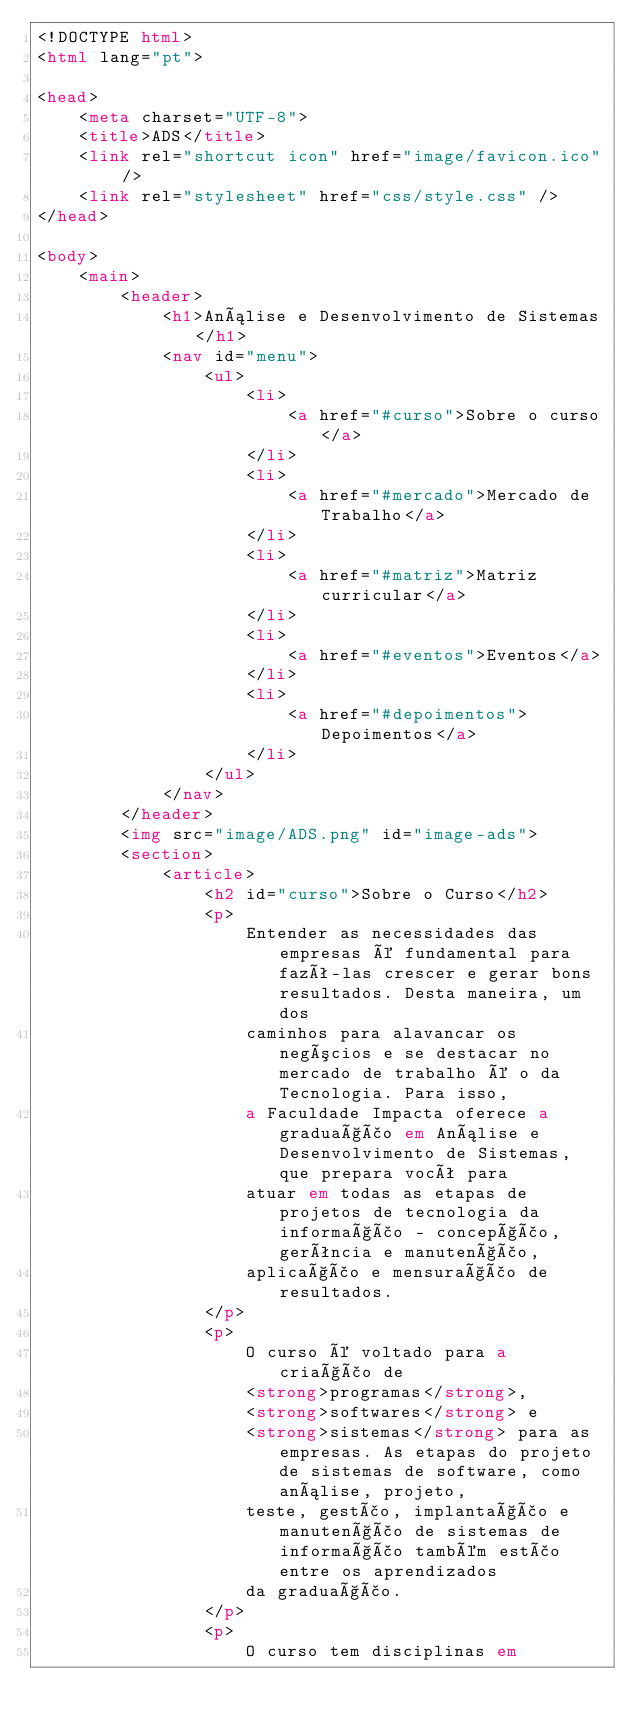Convert code to text. <code><loc_0><loc_0><loc_500><loc_500><_HTML_><!DOCTYPE html>
<html lang="pt">

<head>
    <meta charset="UTF-8">
    <title>ADS</title>
    <link rel="shortcut icon" href="image/favicon.ico" />
    <link rel="stylesheet" href="css/style.css" />
</head>

<body>
    <main>
        <header>
            <h1>Análise e Desenvolvimento de Sistemas</h1>
            <nav id="menu">
                <ul>
                    <li>
                        <a href="#curso">Sobre o curso</a>
                    </li>
                    <li>
                        <a href="#mercado">Mercado de Trabalho</a>
                    </li>
                    <li>
                        <a href="#matriz">Matriz curricular</a>
                    </li>
                    <li>
                        <a href="#eventos">Eventos</a>
                    </li>
                    <li>
                        <a href="#depoimentos">Depoimentos</a>
                    </li>
                </ul>
            </nav>
        </header>
        <img src="image/ADS.png" id="image-ads">
        <section>
            <article>
                <h2 id="curso">Sobre o Curso</h2>
                <p>
                    Entender as necessidades das empresas é fundamental para fazê-las crescer e gerar bons resultados. Desta maneira, um dos
                    caminhos para alavancar os negócios e se destacar no mercado de trabalho é o da Tecnologia. Para isso,
                    a Faculdade Impacta oferece a graduação em Análise e Desenvolvimento de Sistemas, que prepara você para
                    atuar em todas as etapas de projetos de tecnologia da informação - concepção, gerência e manutenção,
                    aplicação e mensuração de resultados.
                </p>
                <p>
                    O curso é voltado para a criação de
                    <strong>programas</strong>,
                    <strong>softwares</strong> e
                    <strong>sistemas</strong> para as empresas. As etapas do projeto de sistemas de software, como análise, projeto,
                    teste, gestão, implantação e manutenção de sistemas de informação também estão entre os aprendizados
                    da graduação.
                </p>
                <p>
                    O curso tem disciplinas em</code> 